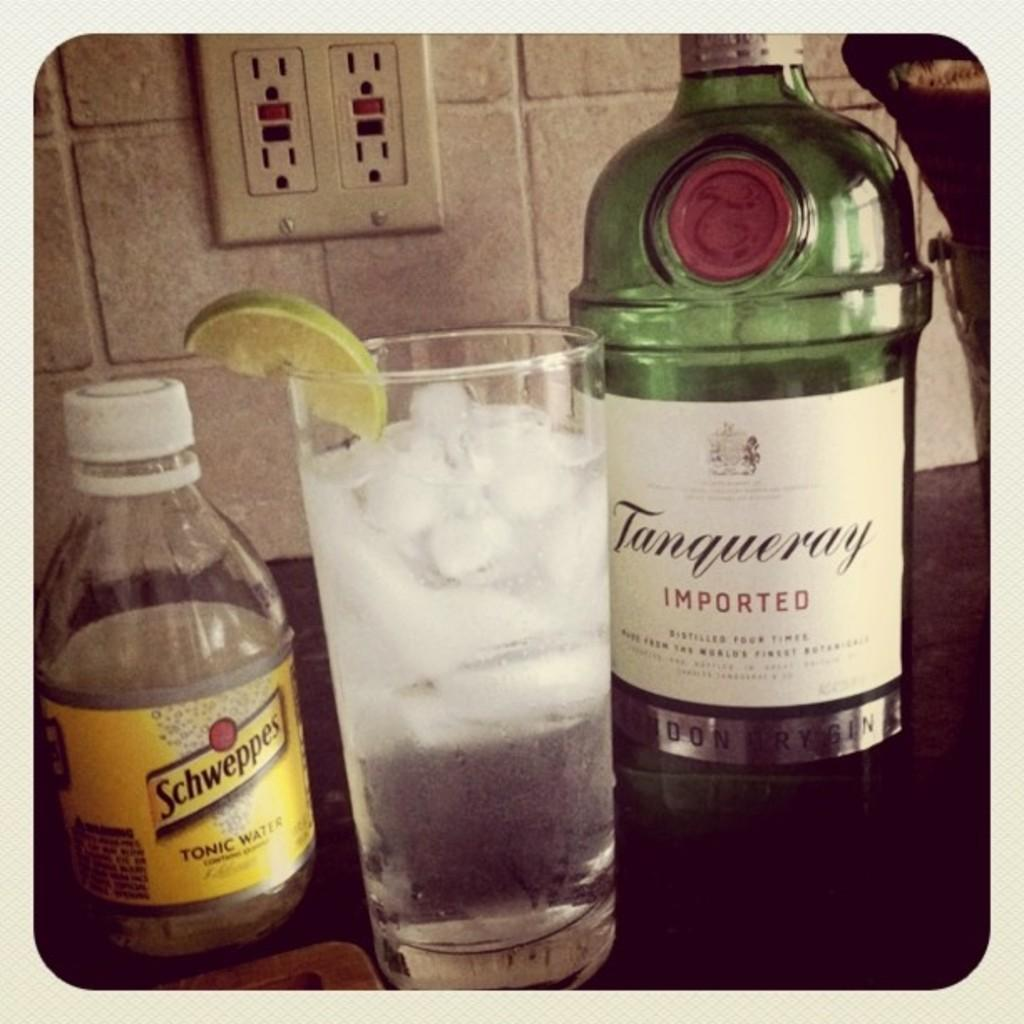<image>
Summarize the visual content of the image. A glass next to an imported bottle of Gin 